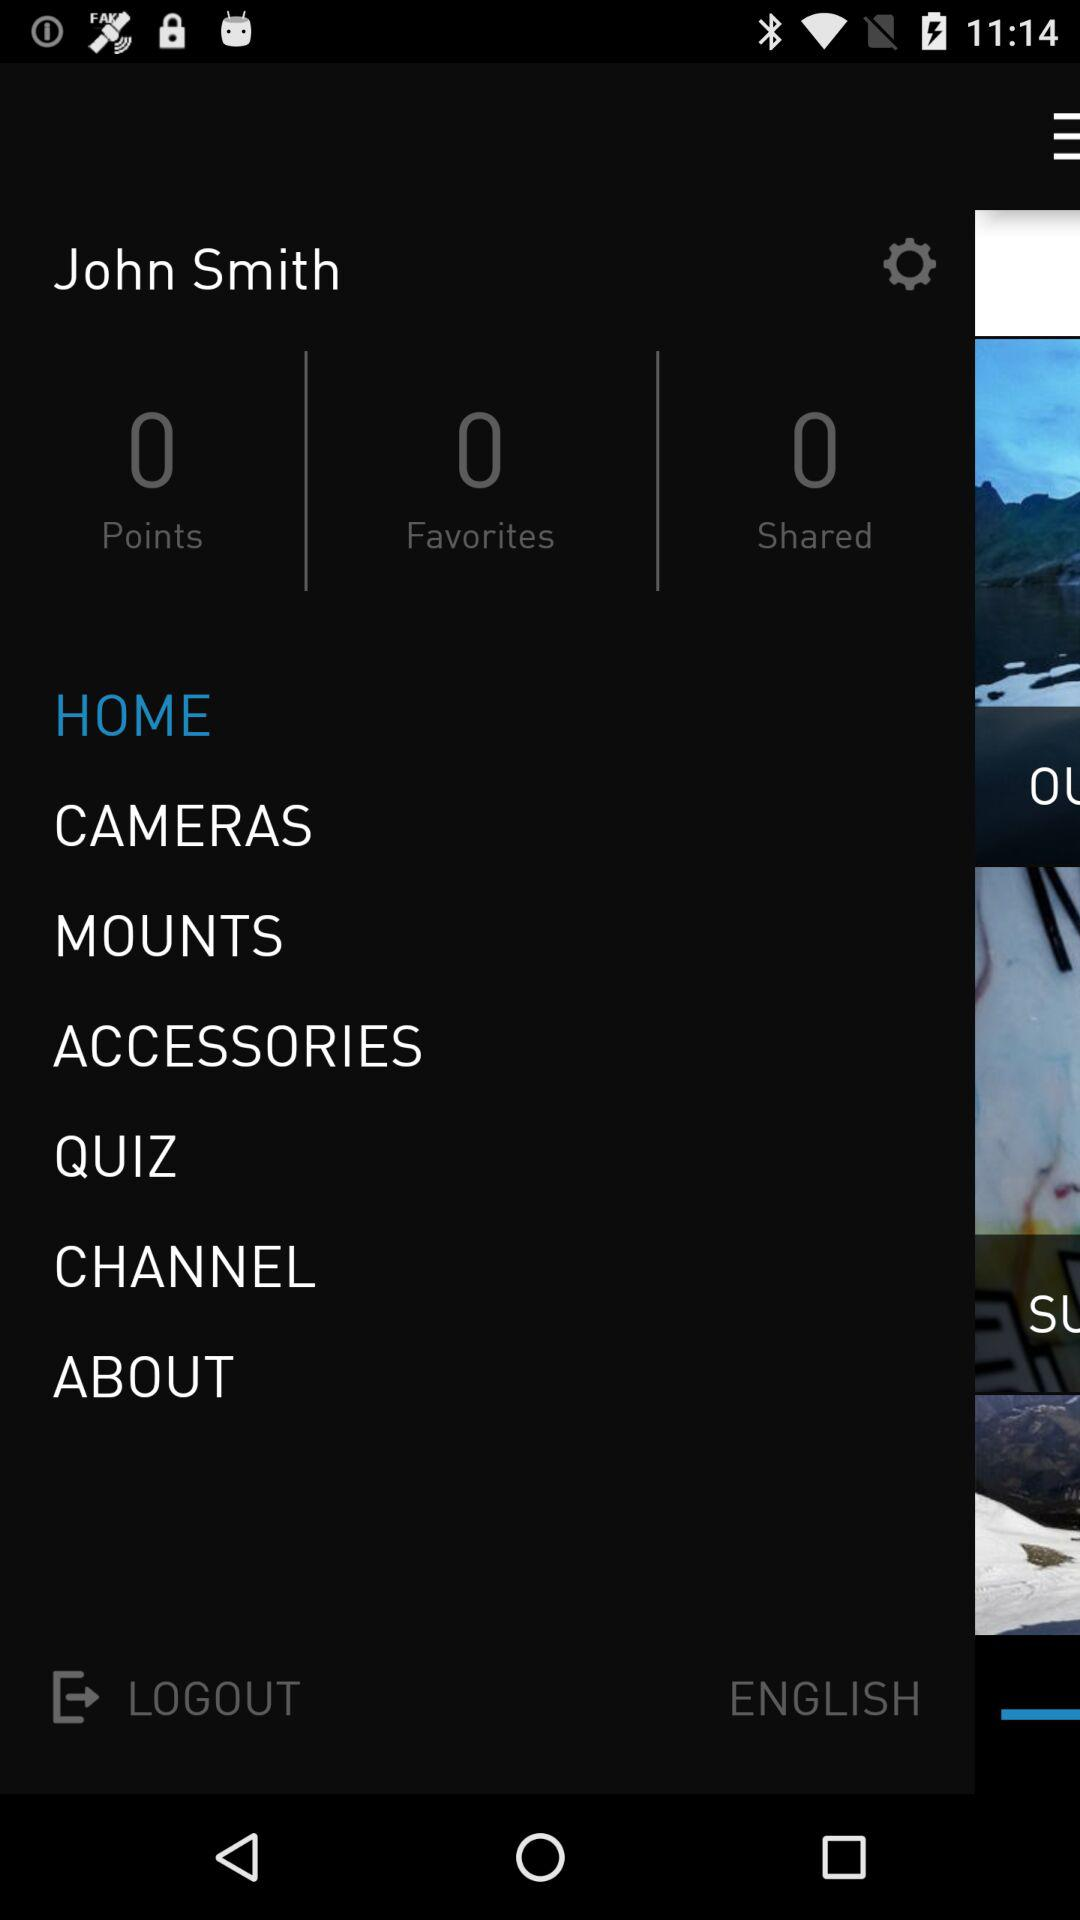What is the name of the user? The name of the user is John Smith. 